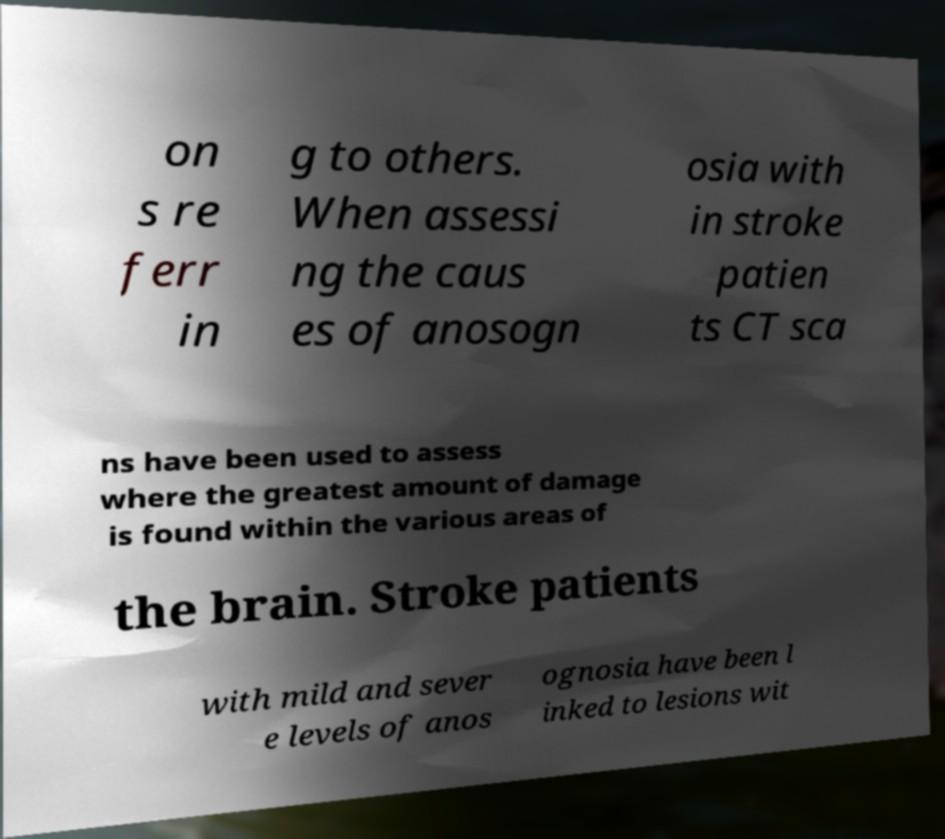Can you read and provide the text displayed in the image?This photo seems to have some interesting text. Can you extract and type it out for me? on s re ferr in g to others. When assessi ng the caus es of anosogn osia with in stroke patien ts CT sca ns have been used to assess where the greatest amount of damage is found within the various areas of the brain. Stroke patients with mild and sever e levels of anos ognosia have been l inked to lesions wit 